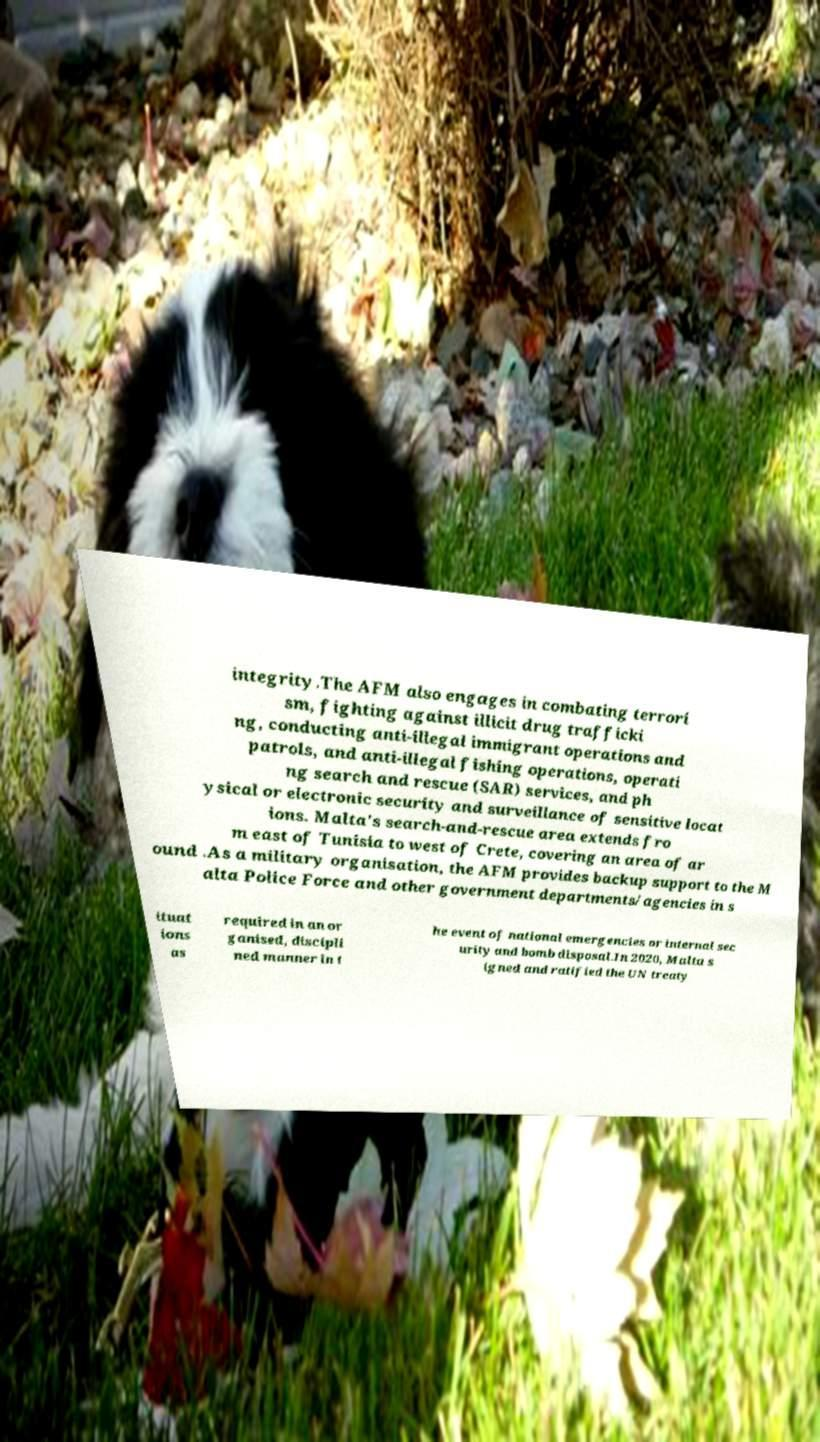Can you read and provide the text displayed in the image?This photo seems to have some interesting text. Can you extract and type it out for me? integrity.The AFM also engages in combating terrori sm, fighting against illicit drug trafficki ng, conducting anti-illegal immigrant operations and patrols, and anti-illegal fishing operations, operati ng search and rescue (SAR) services, and ph ysical or electronic security and surveillance of sensitive locat ions. Malta's search-and-rescue area extends fro m east of Tunisia to west of Crete, covering an area of ar ound .As a military organisation, the AFM provides backup support to the M alta Police Force and other government departments/agencies in s ituat ions as required in an or ganised, discipli ned manner in t he event of national emergencies or internal sec urity and bomb disposal.In 2020, Malta s igned and ratified the UN treaty 